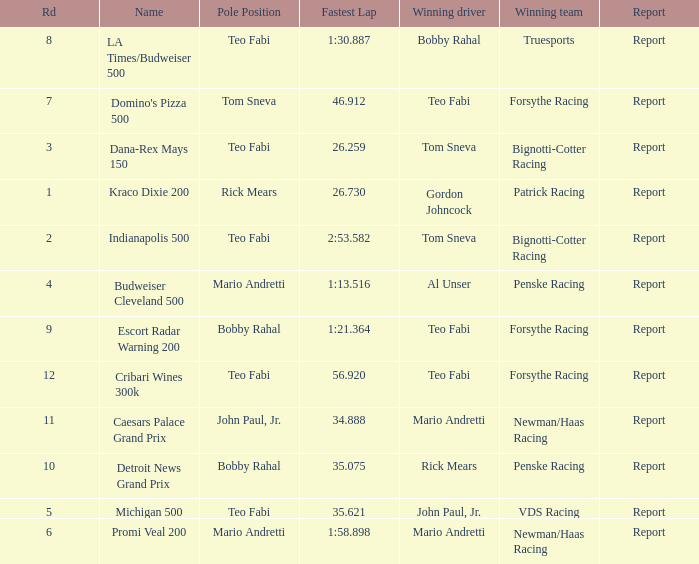Which Rd took place at the Indianapolis 500? 2.0. 